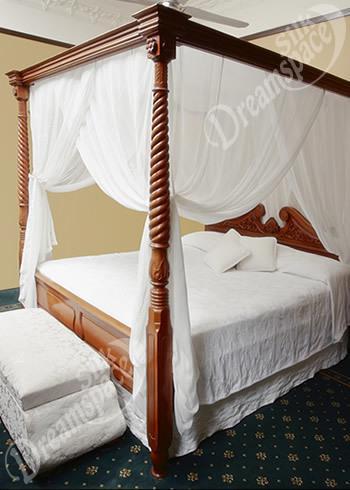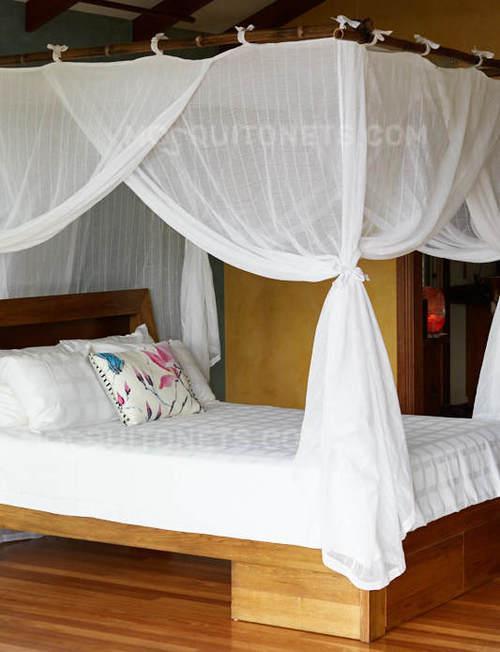The first image is the image on the left, the second image is the image on the right. For the images shown, is this caption "The drapery of one bed frames it as a four poster with a top ruffle, while the other bed drapery falls from a central point above the bed." true? Answer yes or no. No. The first image is the image on the left, the second image is the image on the right. Considering the images on both sides, is "An image shows a ceiling-suspended tent-shaped netting bed canopy." valid? Answer yes or no. No. 